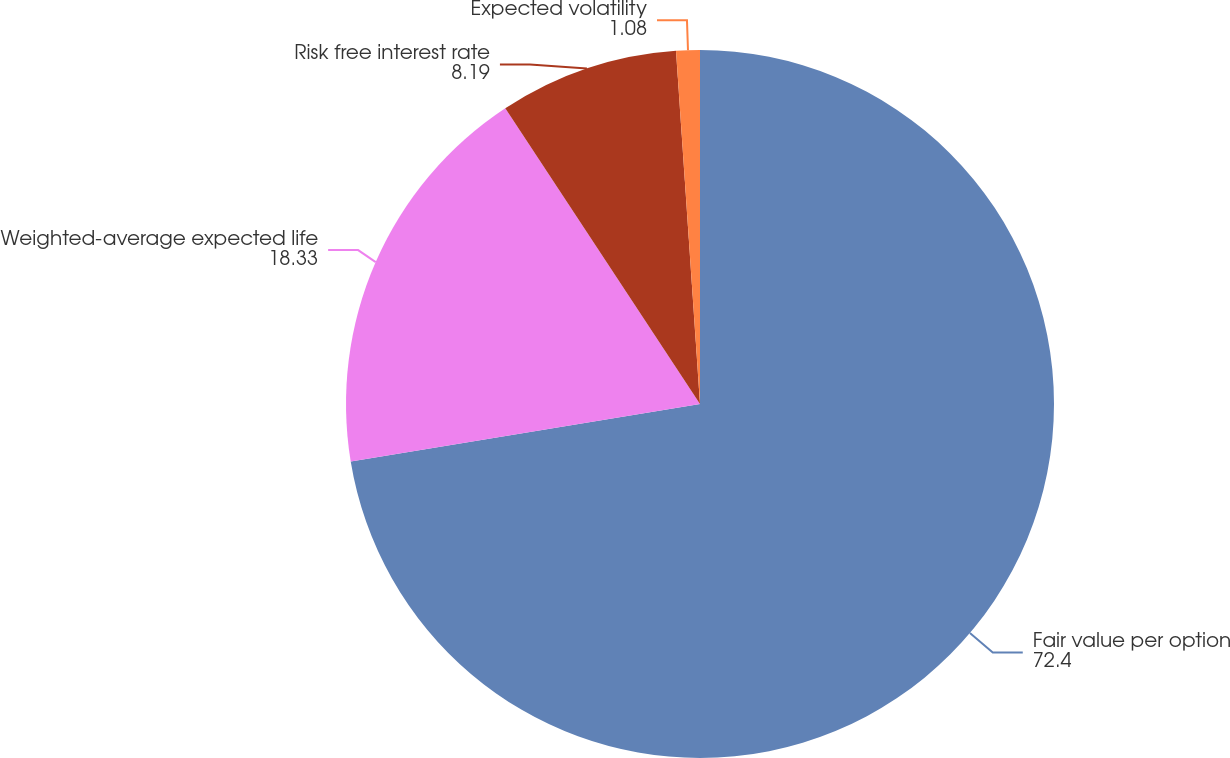Convert chart to OTSL. <chart><loc_0><loc_0><loc_500><loc_500><pie_chart><fcel>Fair value per option<fcel>Weighted-average expected life<fcel>Risk free interest rate<fcel>Expected volatility<nl><fcel>72.4%<fcel>18.33%<fcel>8.19%<fcel>1.08%<nl></chart> 